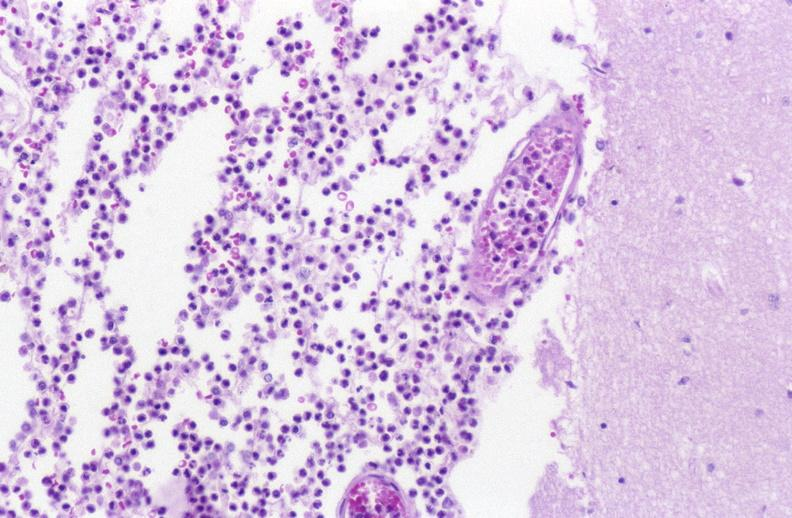does this image show bacterial meningitis?
Answer the question using a single word or phrase. Yes 